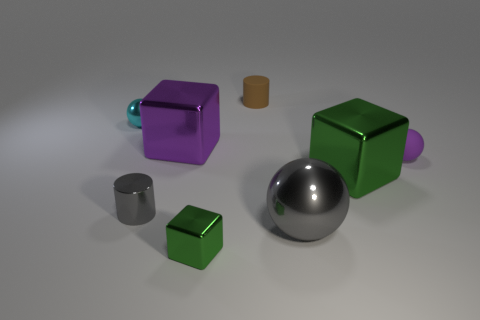There is a tiny cylinder that is the same material as the tiny cyan thing; what is its color?
Your response must be concise. Gray. Do the large thing left of the brown object and the small matte sphere have the same color?
Offer a terse response. Yes. How many blocks are yellow metal objects or small cyan shiny objects?
Give a very brief answer. 0. There is a matte thing behind the rubber thing to the right of the large metallic cube that is right of the tiny green shiny block; how big is it?
Your answer should be compact. Small. There is a purple matte thing that is the same size as the cyan sphere; what is its shape?
Your response must be concise. Sphere. What is the shape of the large green object?
Offer a terse response. Cube. Is the material of the small sphere right of the cyan thing the same as the gray ball?
Your answer should be very brief. No. There is a matte sphere that is to the right of the cylinder on the right side of the tiny green cube; how big is it?
Your answer should be very brief. Small. There is a cube that is both behind the tiny gray cylinder and to the left of the brown thing; what is its color?
Provide a succinct answer. Purple. What is the material of the purple thing that is the same size as the cyan thing?
Offer a very short reply. Rubber. 